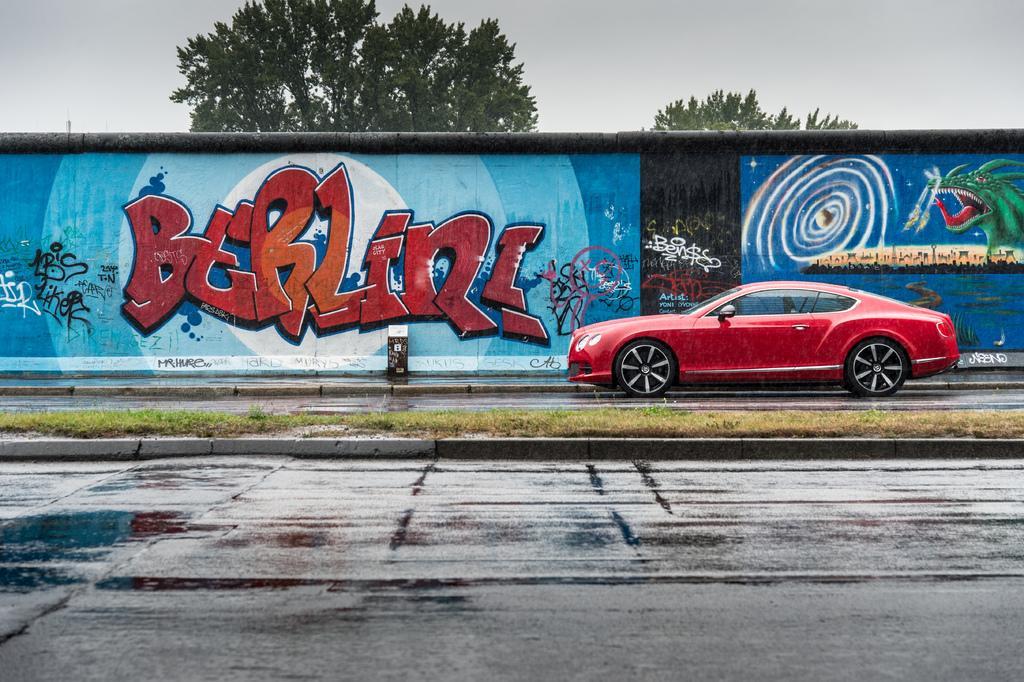Could you give a brief overview of what you see in this image? In the picture I can see a red color car on the road. In the background I can see a wall which has paintings on it. In the background I can see the sky and trees. Here I can see the grass and some other objects. 